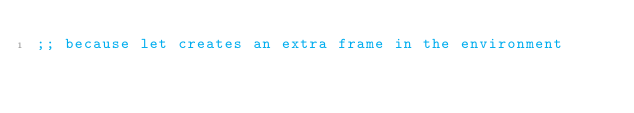Convert code to text. <code><loc_0><loc_0><loc_500><loc_500><_Scheme_>;; because let creates an extra frame in the environment
</code> 